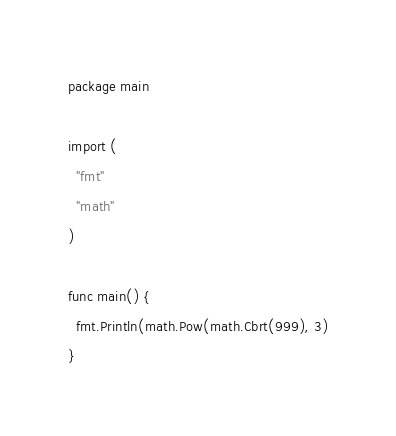Convert code to text. <code><loc_0><loc_0><loc_500><loc_500><_Go_>package main

import (
  "fmt"
  "math"
)

func main() {
  fmt.Println(math.Pow(math.Cbrt(999), 3)
}</code> 